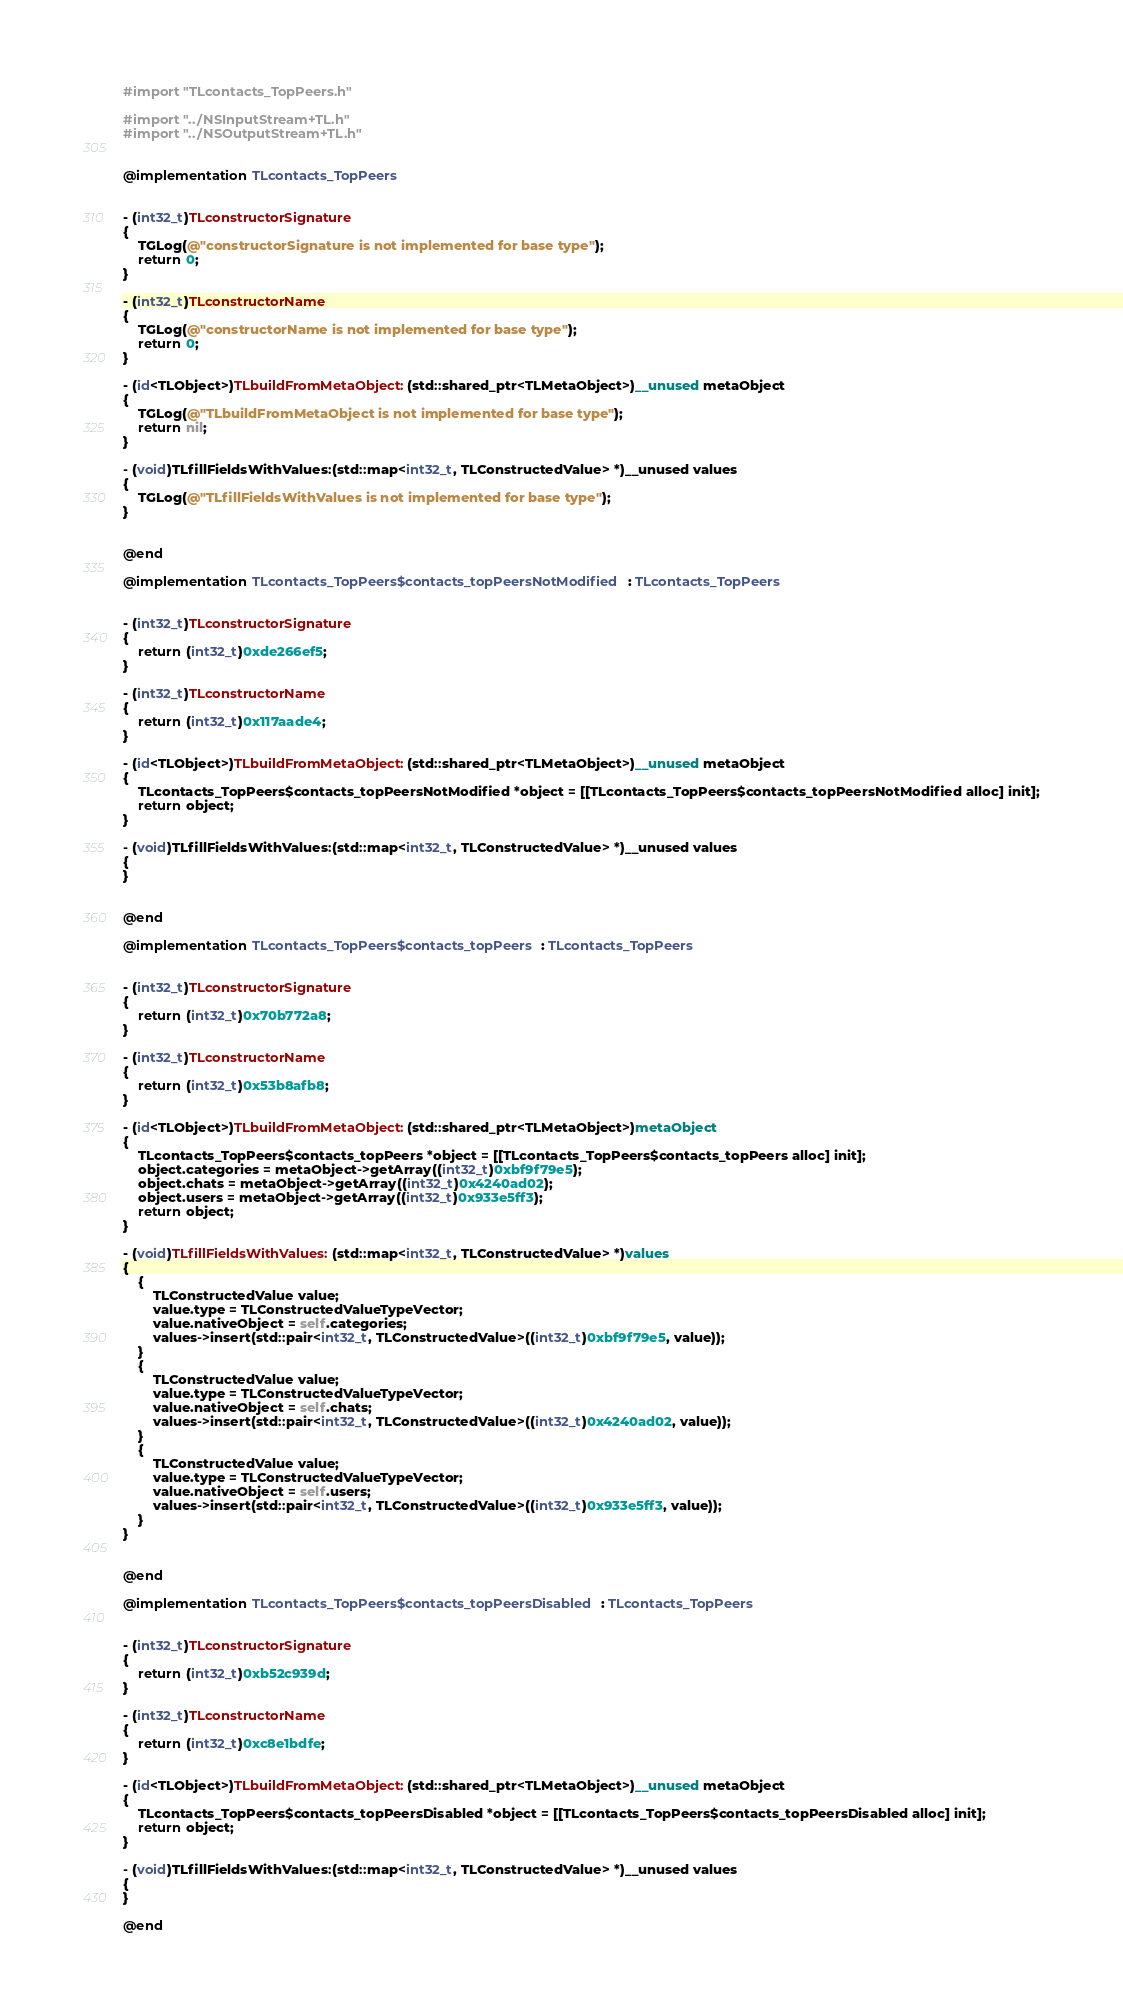<code> <loc_0><loc_0><loc_500><loc_500><_ObjectiveC_>#import "TLcontacts_TopPeers.h"

#import "../NSInputStream+TL.h"
#import "../NSOutputStream+TL.h"


@implementation TLcontacts_TopPeers


- (int32_t)TLconstructorSignature
{
    TGLog(@"constructorSignature is not implemented for base type");
    return 0;
}

- (int32_t)TLconstructorName
{
    TGLog(@"constructorName is not implemented for base type");
    return 0;
}

- (id<TLObject>)TLbuildFromMetaObject:(std::shared_ptr<TLMetaObject>)__unused metaObject
{
    TGLog(@"TLbuildFromMetaObject is not implemented for base type");
    return nil;
}

- (void)TLfillFieldsWithValues:(std::map<int32_t, TLConstructedValue> *)__unused values
{
    TGLog(@"TLfillFieldsWithValues is not implemented for base type");
}


@end

@implementation TLcontacts_TopPeers$contacts_topPeersNotModified : TLcontacts_TopPeers


- (int32_t)TLconstructorSignature
{
    return (int32_t)0xde266ef5;
}

- (int32_t)TLconstructorName
{
    return (int32_t)0x117aade4;
}

- (id<TLObject>)TLbuildFromMetaObject:(std::shared_ptr<TLMetaObject>)__unused metaObject
{
    TLcontacts_TopPeers$contacts_topPeersNotModified *object = [[TLcontacts_TopPeers$contacts_topPeersNotModified alloc] init];
    return object;
}

- (void)TLfillFieldsWithValues:(std::map<int32_t, TLConstructedValue> *)__unused values
{
}


@end

@implementation TLcontacts_TopPeers$contacts_topPeers : TLcontacts_TopPeers


- (int32_t)TLconstructorSignature
{
    return (int32_t)0x70b772a8;
}

- (int32_t)TLconstructorName
{
    return (int32_t)0x53b8afb8;
}

- (id<TLObject>)TLbuildFromMetaObject:(std::shared_ptr<TLMetaObject>)metaObject
{
    TLcontacts_TopPeers$contacts_topPeers *object = [[TLcontacts_TopPeers$contacts_topPeers alloc] init];
    object.categories = metaObject->getArray((int32_t)0xbf9f79e5);
    object.chats = metaObject->getArray((int32_t)0x4240ad02);
    object.users = metaObject->getArray((int32_t)0x933e5ff3);
    return object;
}

- (void)TLfillFieldsWithValues:(std::map<int32_t, TLConstructedValue> *)values
{
    {
        TLConstructedValue value;
        value.type = TLConstructedValueTypeVector;
        value.nativeObject = self.categories;
        values->insert(std::pair<int32_t, TLConstructedValue>((int32_t)0xbf9f79e5, value));
    }
    {
        TLConstructedValue value;
        value.type = TLConstructedValueTypeVector;
        value.nativeObject = self.chats;
        values->insert(std::pair<int32_t, TLConstructedValue>((int32_t)0x4240ad02, value));
    }
    {
        TLConstructedValue value;
        value.type = TLConstructedValueTypeVector;
        value.nativeObject = self.users;
        values->insert(std::pair<int32_t, TLConstructedValue>((int32_t)0x933e5ff3, value));
    }
}


@end

@implementation TLcontacts_TopPeers$contacts_topPeersDisabled : TLcontacts_TopPeers


- (int32_t)TLconstructorSignature
{
    return (int32_t)0xb52c939d;
}

- (int32_t)TLconstructorName
{
    return (int32_t)0xc8e1bdfe;
}

- (id<TLObject>)TLbuildFromMetaObject:(std::shared_ptr<TLMetaObject>)__unused metaObject
{
    TLcontacts_TopPeers$contacts_topPeersDisabled *object = [[TLcontacts_TopPeers$contacts_topPeersDisabled alloc] init];
    return object;
}

- (void)TLfillFieldsWithValues:(std::map<int32_t, TLConstructedValue> *)__unused values
{
}

@end
</code> 